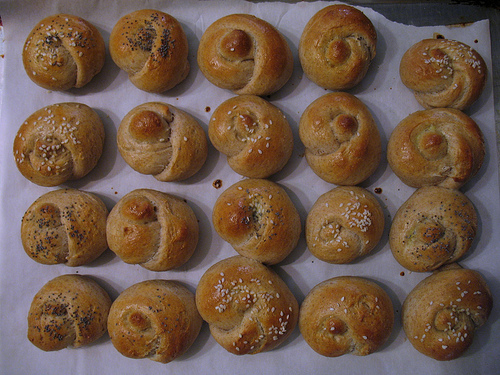<image>
Is the sheep in front of the beard? No. The sheep is not in front of the beard. The spatial positioning shows a different relationship between these objects. 